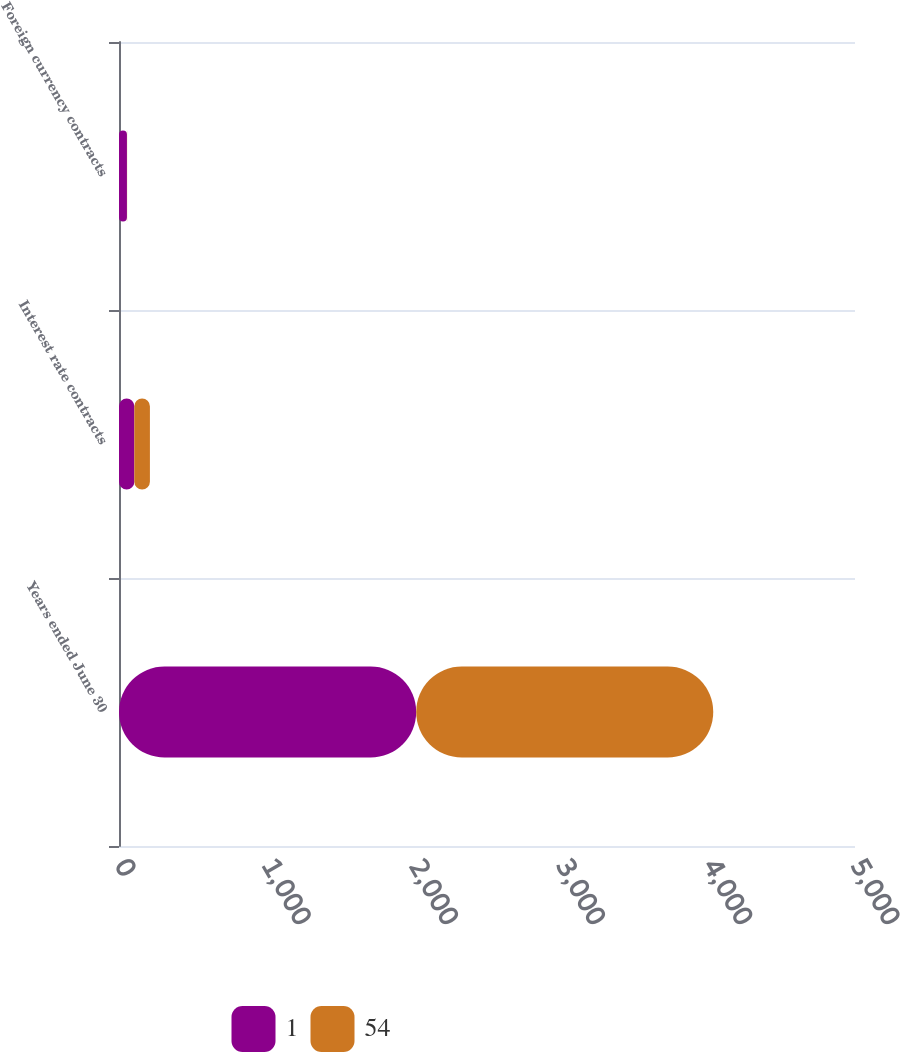Convert chart to OTSL. <chart><loc_0><loc_0><loc_500><loc_500><stacked_bar_chart><ecel><fcel>Years ended June 30<fcel>Interest rate contracts<fcel>Foreign currency contracts<nl><fcel>1<fcel>2019<fcel>104<fcel>54<nl><fcel>54<fcel>2018<fcel>106<fcel>1<nl></chart> 